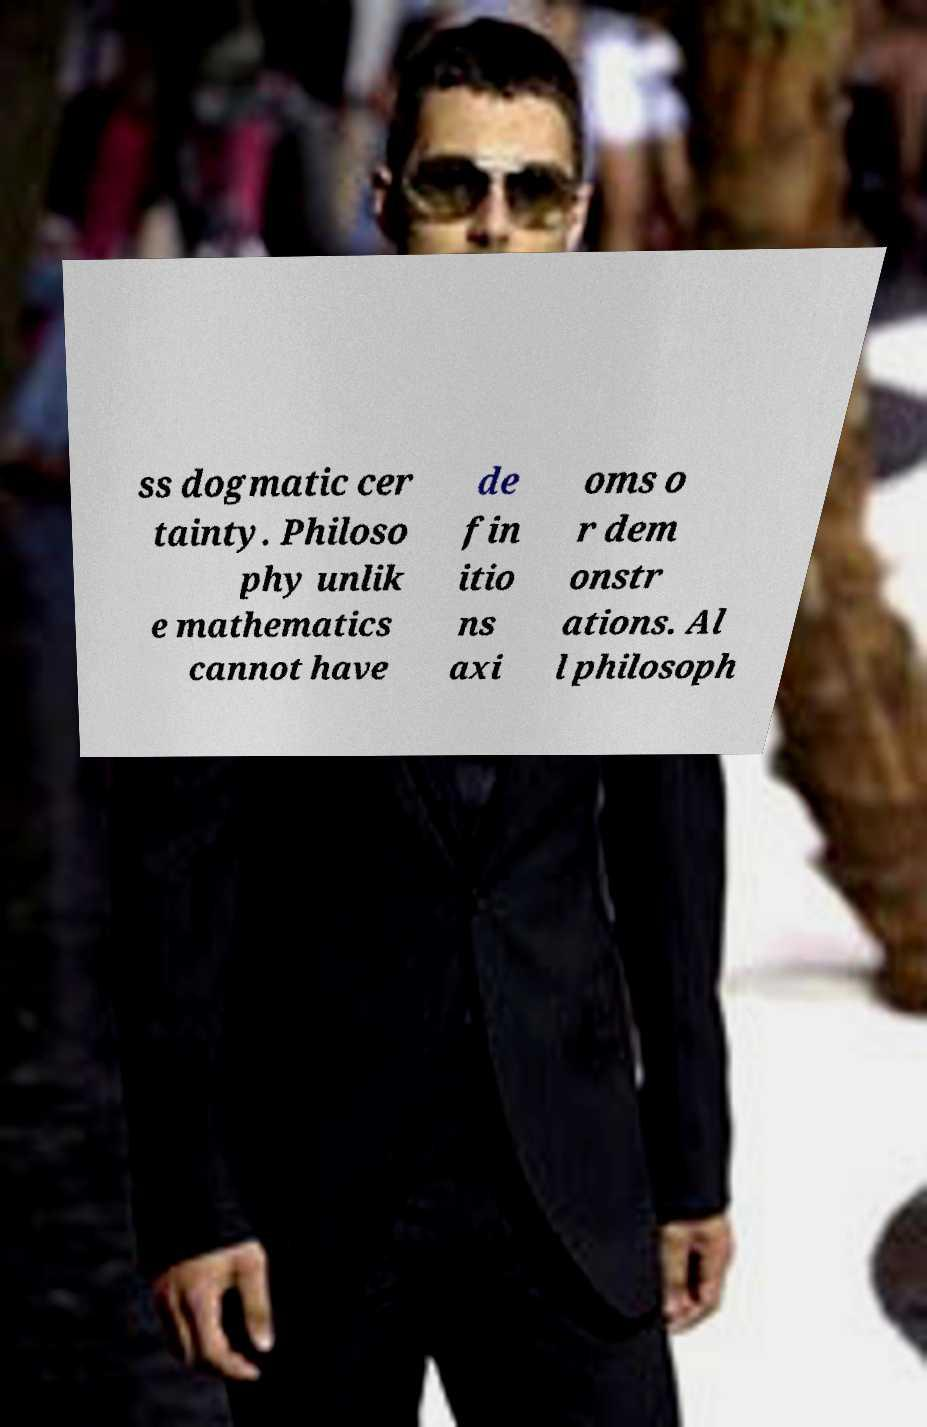Could you assist in decoding the text presented in this image and type it out clearly? ss dogmatic cer tainty. Philoso phy unlik e mathematics cannot have de fin itio ns axi oms o r dem onstr ations. Al l philosoph 